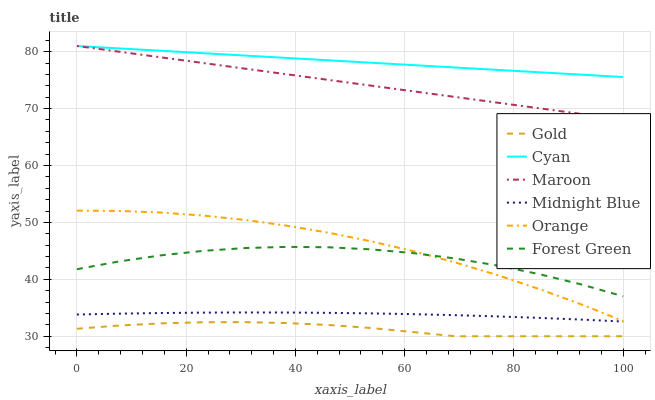Does Gold have the minimum area under the curve?
Answer yes or no. Yes. Does Cyan have the maximum area under the curve?
Answer yes or no. Yes. Does Maroon have the minimum area under the curve?
Answer yes or no. No. Does Maroon have the maximum area under the curve?
Answer yes or no. No. Is Maroon the smoothest?
Answer yes or no. Yes. Is Forest Green the roughest?
Answer yes or no. Yes. Is Gold the smoothest?
Answer yes or no. No. Is Gold the roughest?
Answer yes or no. No. Does Gold have the lowest value?
Answer yes or no. Yes. Does Maroon have the lowest value?
Answer yes or no. No. Does Cyan have the highest value?
Answer yes or no. Yes. Does Gold have the highest value?
Answer yes or no. No. Is Midnight Blue less than Forest Green?
Answer yes or no. Yes. Is Cyan greater than Midnight Blue?
Answer yes or no. Yes. Does Orange intersect Forest Green?
Answer yes or no. Yes. Is Orange less than Forest Green?
Answer yes or no. No. Is Orange greater than Forest Green?
Answer yes or no. No. Does Midnight Blue intersect Forest Green?
Answer yes or no. No. 